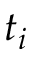<formula> <loc_0><loc_0><loc_500><loc_500>t _ { i }</formula> 